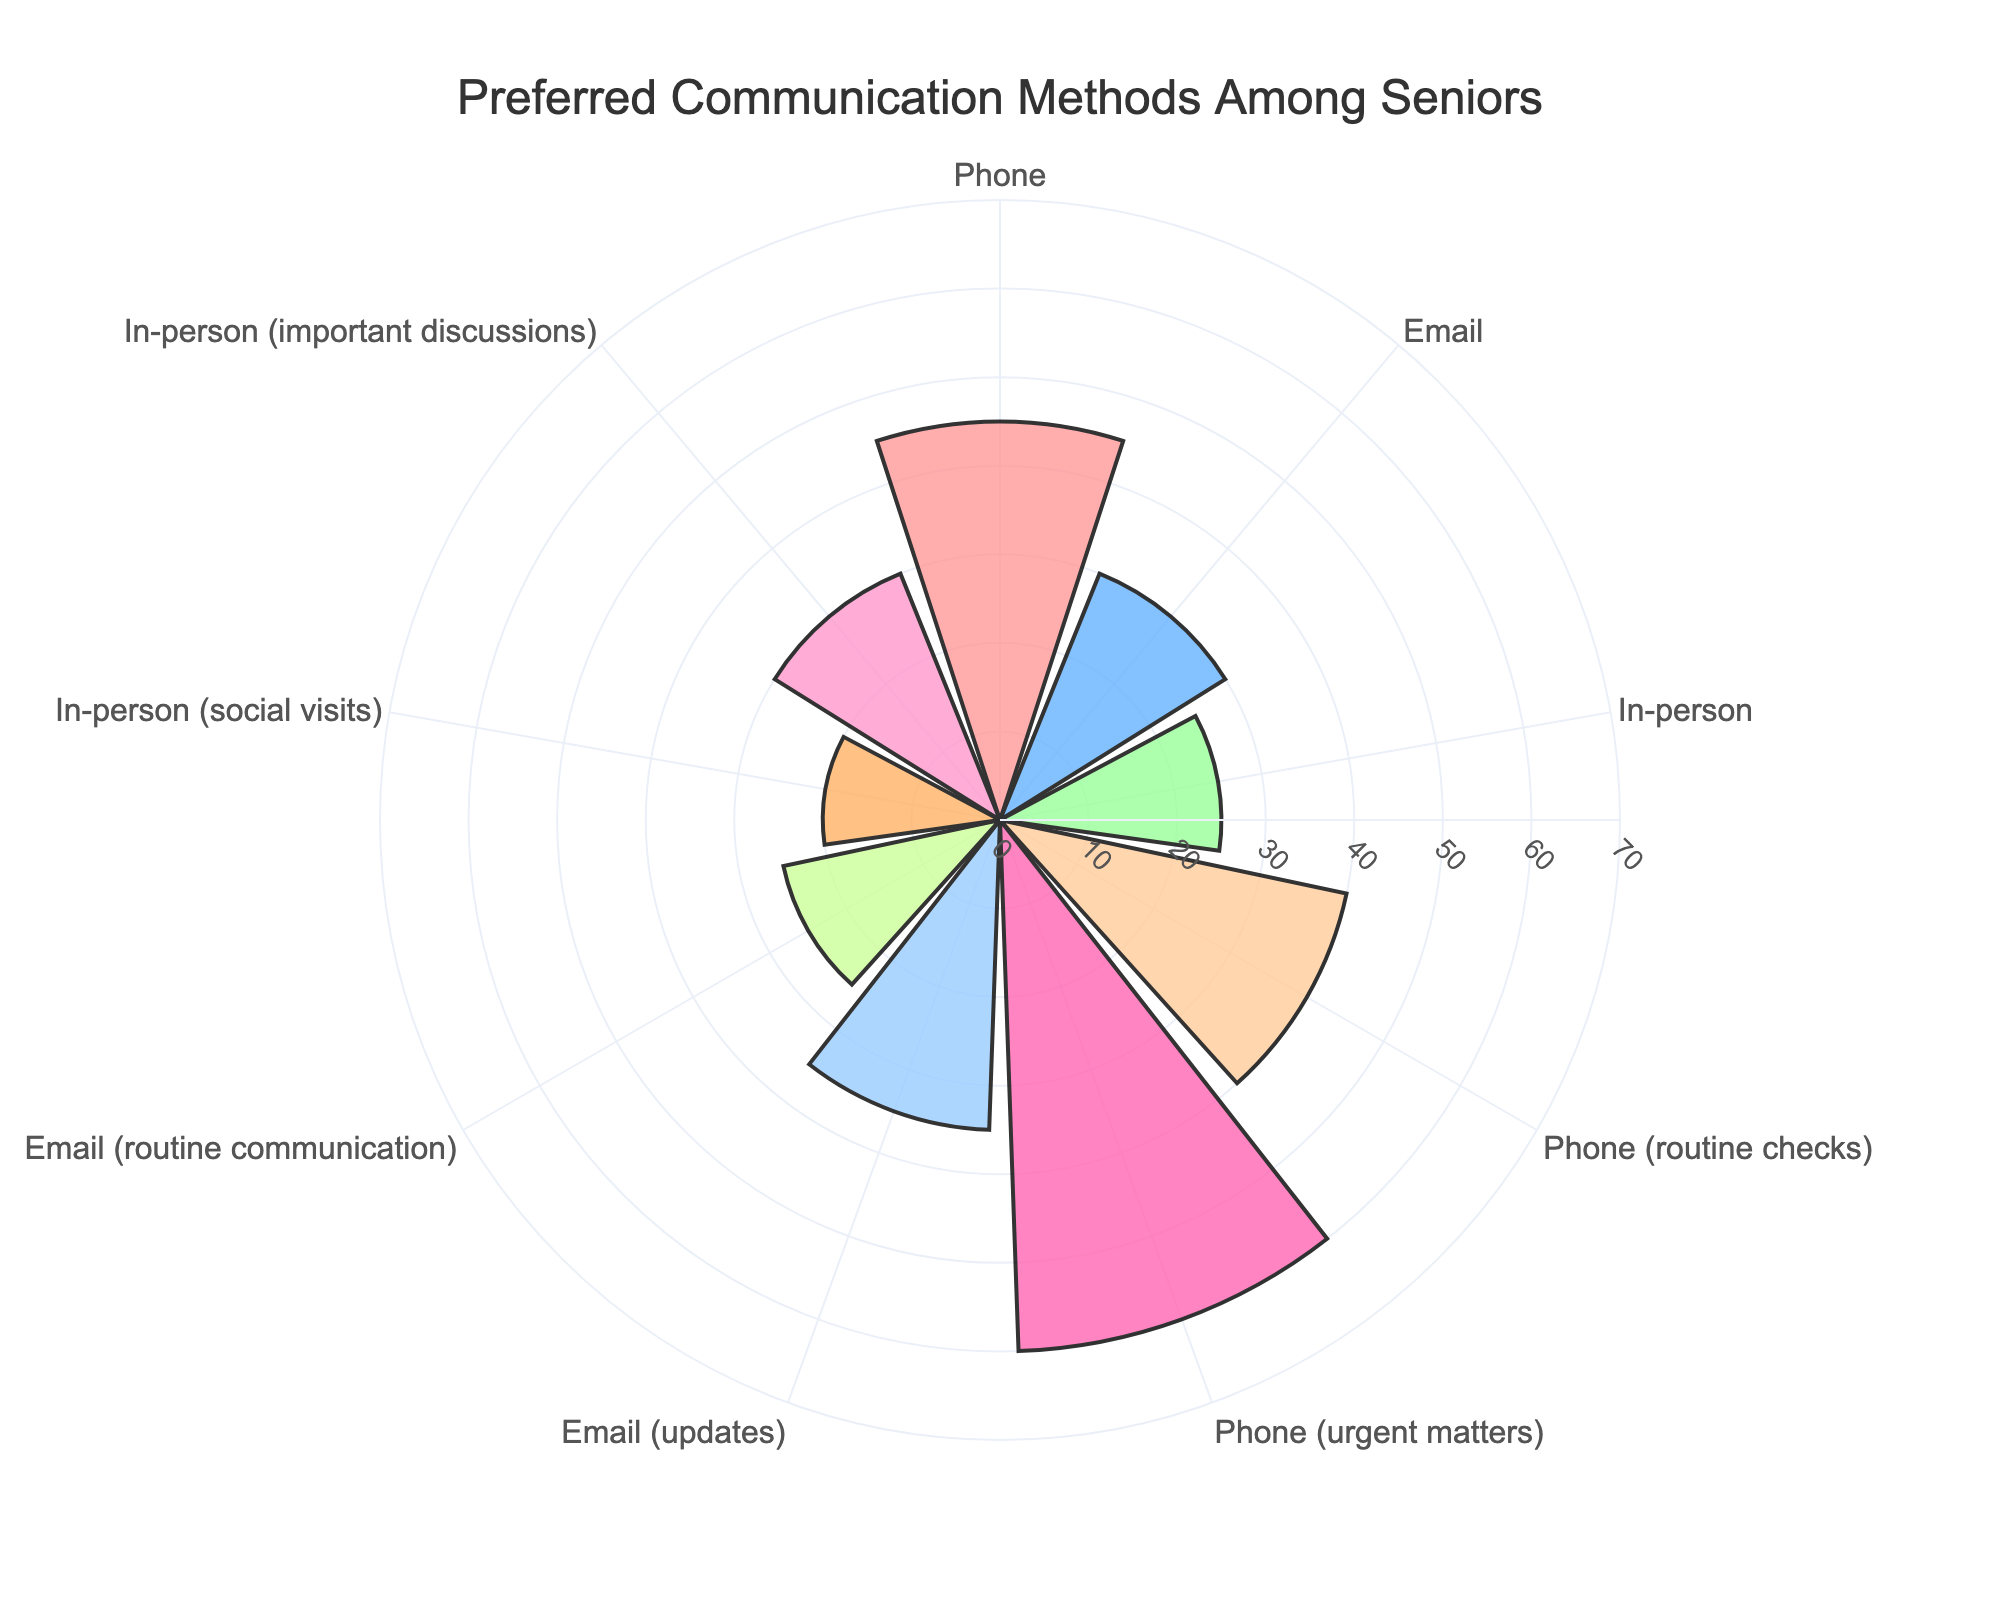What's the title of the chart? The title is visible at the top of the chart. It summarizes the main subject of the figure.
Answer: Preferred Communication Methods Among Seniors How many communication methods are displayed on the chart? To find this, count the unique labels around the polar axis.
Answer: 9 Which communication method has the highest percentage? By looking for the bar that extends the farthest from the center, we see that 'Phone (urgent matters)' has the highest percentage.
Answer: Phone (urgent matters) What is the sum of the percentages for Email (updates) and In-person (social visits)? First, find the percentages for 'Email (updates)' (35) and 'In-person (social visits)' (20) from the chart and add them: 35 + 20.
Answer: 55 Which communication method has a lower percentage, Email (routine communication) or In-person (social visits)? Refer to the distances from the center for these two bars. 'Email (routine communication)' is at 25 and 'In-person (social visits)' is at 20, making 'In-person (social visits)' lower.
Answer: In-person (social visits) What is the difference in percentage between the highest and lowest preferred communication methods? The highest percentage from the chart is 'Phone (urgent matters)' at 60. The lowest is 'In-person (social visits)' at 20. Subtract the lowest from the highest: 60 - 20.
Answer: 40 Which communication method associated with routine tasks has the higher percentage, Phone or Email? Look at 'Phone (routine checks)' (40) and 'Email (routine communication)' (25). 'Phone (routine checks)' is higher.
Answer: Phone (routine checks) What is the average percentage for Phone-related communication methods? The percentages for Phone-related methods are 45, 40, and 60. Calculate the average: (45 + 40 + 60) / 3.
Answer: 48.33 How many communication methods have a percentage below 30? Count the methods with percentages less than 30: Email (routine communication) - 25, and In-person (social visits) - 20.
Answer: 2 Which method has the second highest percentage among all categories? Find the percentages in descending order: 60 (Phone (urgent matters)), then 45 (Phone), making 'Phone' the second highest.
Answer: Phone 